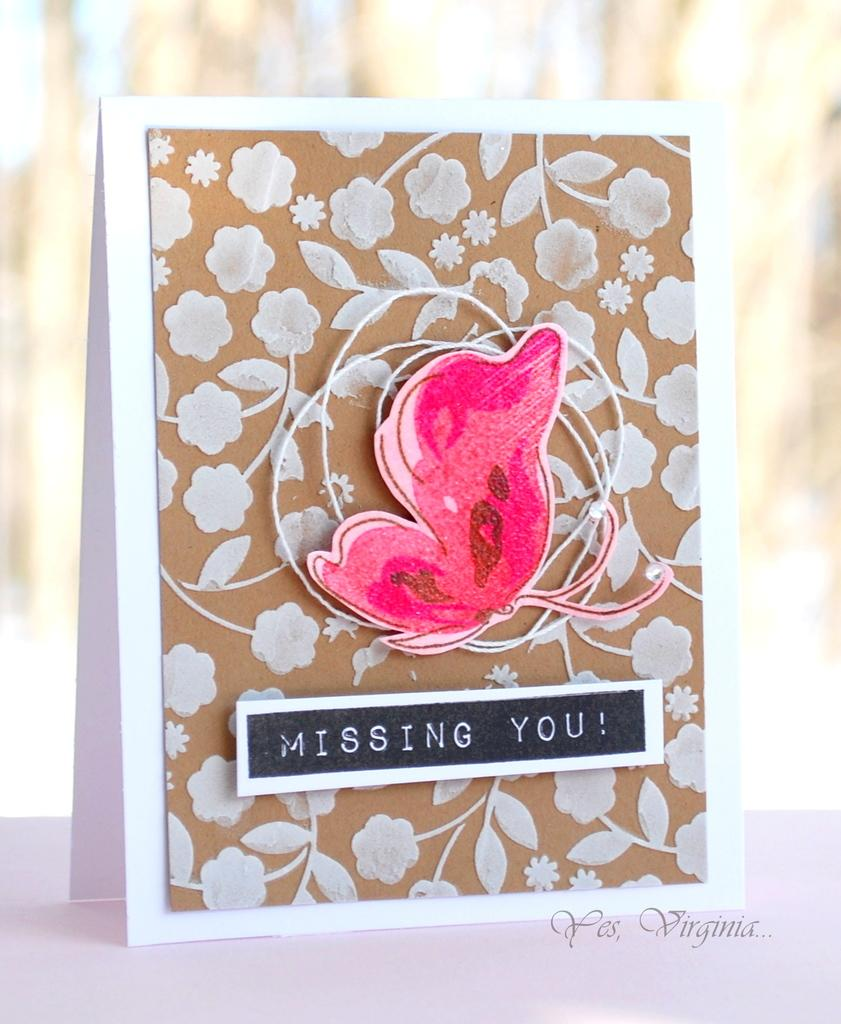What is present on the card in the image? There is text on the card in the image. What is the color of the surface the card is placed on? The card is on a white surface. What scent can be detected from the card in the image? There is no information about the scent of the card in the image, as the facts provided only mention the presence of text on the card. 